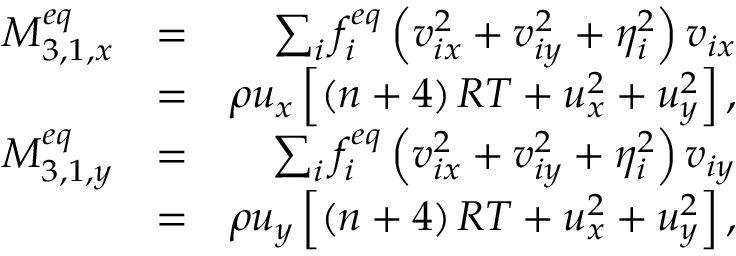Convert formula to latex. <formula><loc_0><loc_0><loc_500><loc_500>\begin{array} { r l r } { M _ { 3 , 1 , x } ^ { e q } } & { = } & { \sum _ { i } { f _ { i } ^ { e q } \left ( { v _ { i x } ^ { 2 } + v _ { i y } ^ { 2 } + \eta _ { i } ^ { 2 } } \right ) { v _ { i x } } } } \\ & { = } & { \rho { u _ { x } } \left [ { \left ( { n + 4 } \right ) R T + u _ { x } ^ { 2 } + u _ { y } ^ { 2 } } \right ] , } \\ { M _ { 3 , 1 , y } ^ { e q } } & { = } & { \sum _ { i } { f _ { i } ^ { e q } \left ( { v _ { i x } ^ { 2 } + v _ { i y } ^ { 2 } + \eta _ { i } ^ { 2 } } \right ) { v _ { i y } } } } \\ & { = } & { \rho { u _ { y } } \left [ { \left ( { n + 4 } \right ) R T + u _ { x } ^ { 2 } + u _ { y } ^ { 2 } } \right ] , } \end{array}</formula> 